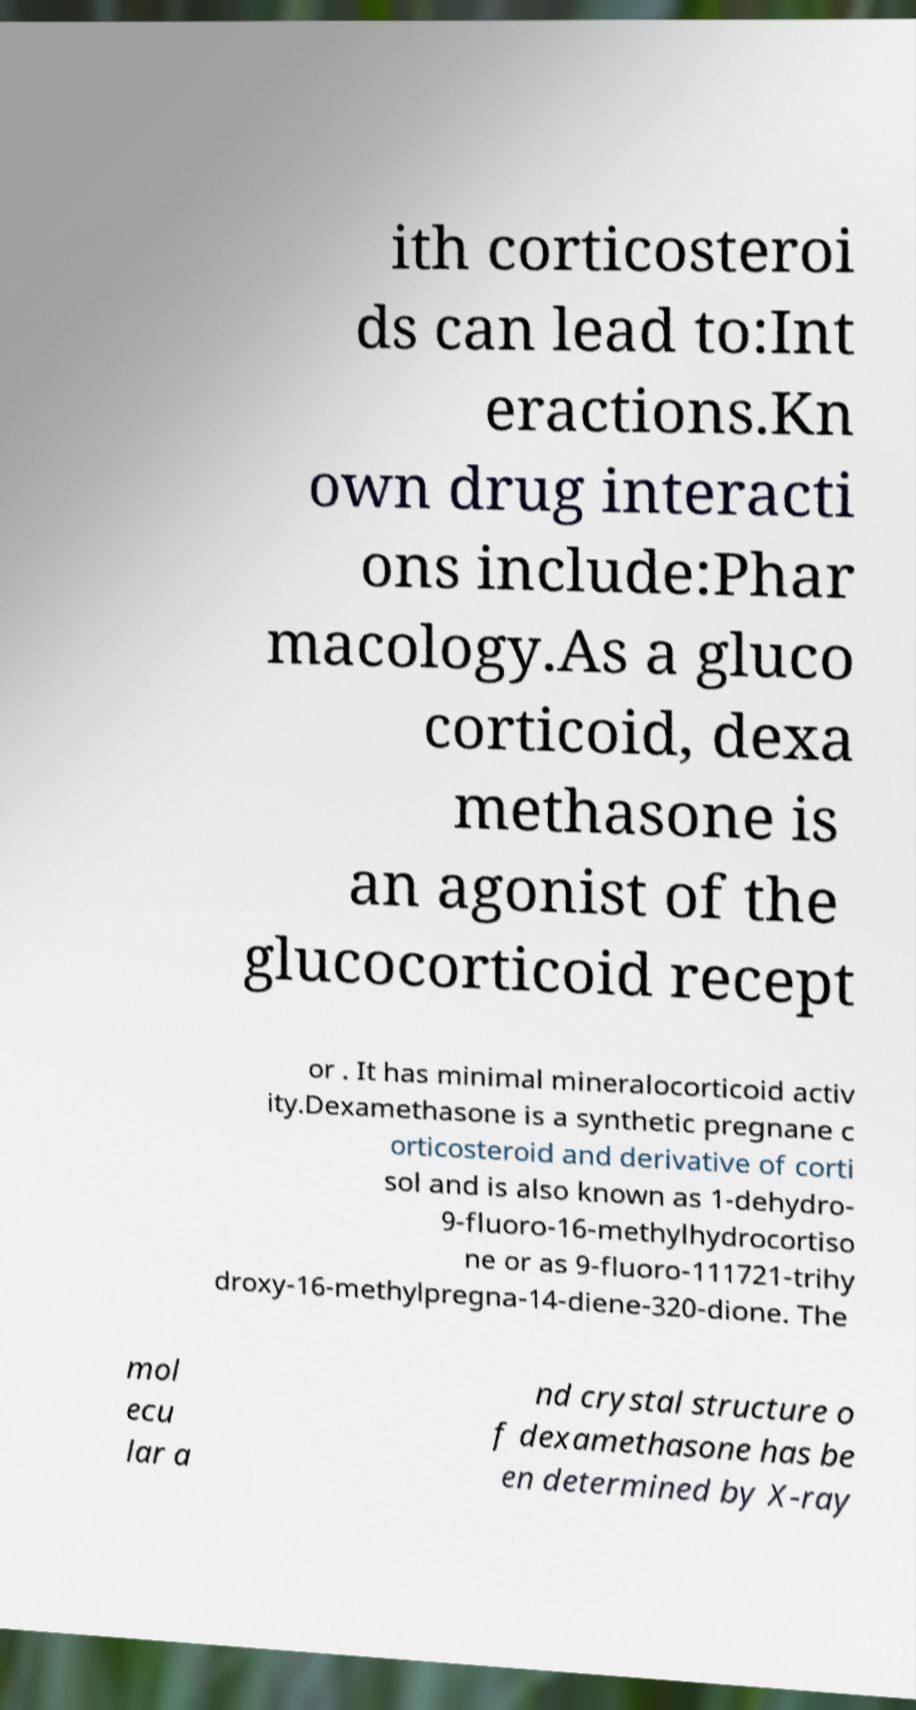Please identify and transcribe the text found in this image. ith corticosteroi ds can lead to:Int eractions.Kn own drug interacti ons include:Phar macology.As a gluco corticoid, dexa methasone is an agonist of the glucocorticoid recept or . It has minimal mineralocorticoid activ ity.Dexamethasone is a synthetic pregnane c orticosteroid and derivative of corti sol and is also known as 1-dehydro- 9-fluoro-16-methylhydrocortiso ne or as 9-fluoro-111721-trihy droxy-16-methylpregna-14-diene-320-dione. The mol ecu lar a nd crystal structure o f dexamethasone has be en determined by X-ray 